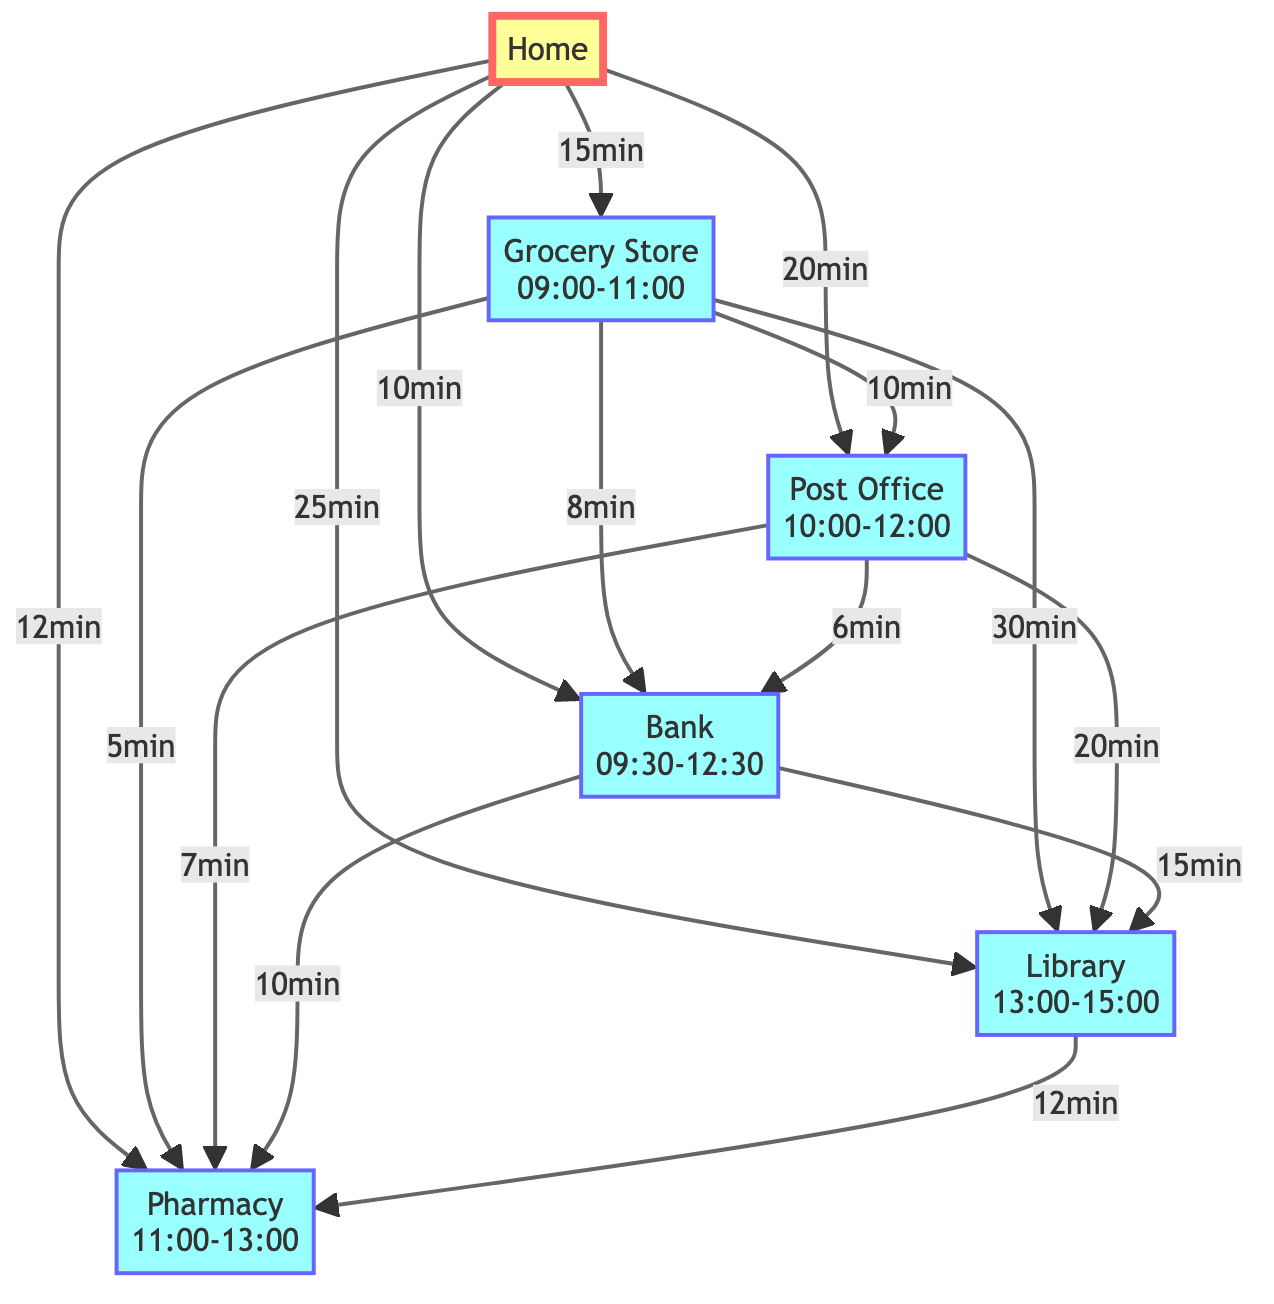What is the travel time from Home to the Grocery Store? The diagram indicates a direct edge from Home to Grocery Store with a labeled travel time of 15 minutes.
Answer: 15 minutes What is the time window for the Pharmacy? The Pharmacy node in the diagram explicitly states its time window is from 11:00 to 13:00.
Answer: 11:00-13:00 How many total nodes are there in the diagram? By counting the unique locations listed in the nodes (Home, Grocery Store, Post Office, Bank, Library, Pharmacy), we find a total of 6 nodes.
Answer: 6 From which location can you reach the Library the fastest? Evaluating the paths leading to the Library, the shortest travel time is from the Post Office (20 minutes), compared to other routes.
Answer: Post Office What is the latest time you can leave the Grocery Store to reach the Post Office within its time window? The Post Office must be reached by 12:00, and with a travel time of 10 minutes from Grocery Store, you must leave by 11:50.
Answer: 11:50 Which two locations have a direct connection with the shortest travel time? Observing the edges, Grocery Store to Pharmacy has the shortest travel time of 5 minutes between two connected nodes.
Answer: Grocery Store and Pharmacy If you start from Home at 09:00, which errands can you complete before 13:00? Starting at 09:00, you can reach Grocery Store and Post Office within their respective time windows, then visit Pharmacy before 13:00.
Answer: Grocery Store, Post Office, Pharmacy What is the total travel time required to go from Home to the Bank and then to the Library? The travel path is Home to Bank (10 minutes), then Bank to Library (15 minutes), totaling 25 minutes.
Answer: 25 minutes Which location is reachable directly from Home but not during the Grocery Store's time window? The Library is reachable from Home directly, but it is not available during the Grocery Store's time window, which ends at 11:00.
Answer: Library 